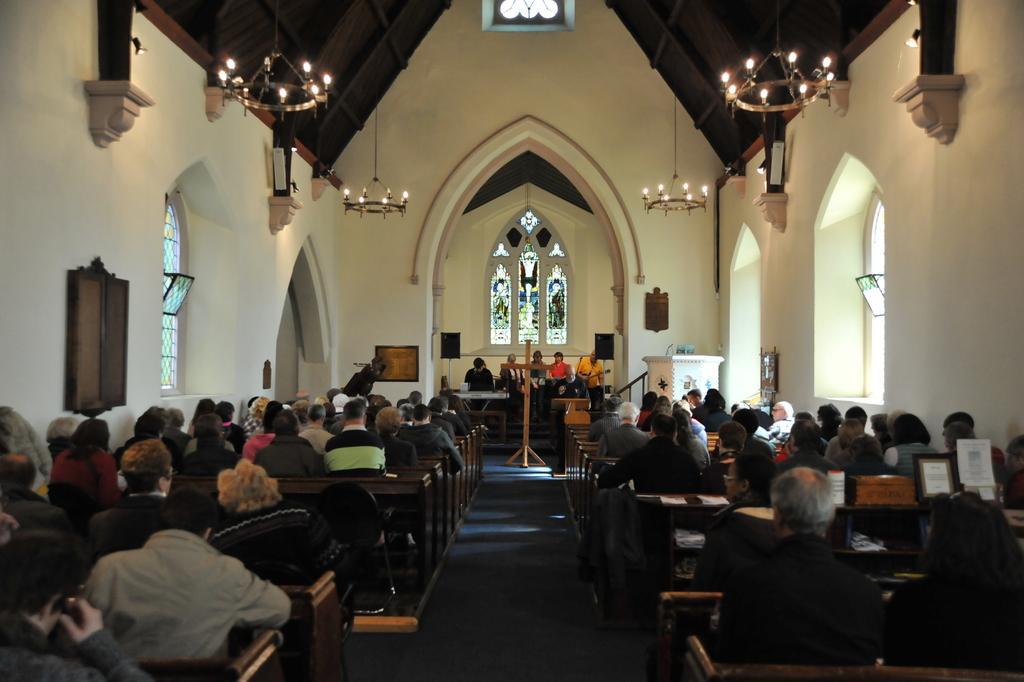In one or two sentences, can you explain what this image depicts? In this picture I can see group of people are sitting in the church. In the background I can see cross, people and windows. I can also see chandeliers and some objects attached to the wall. 